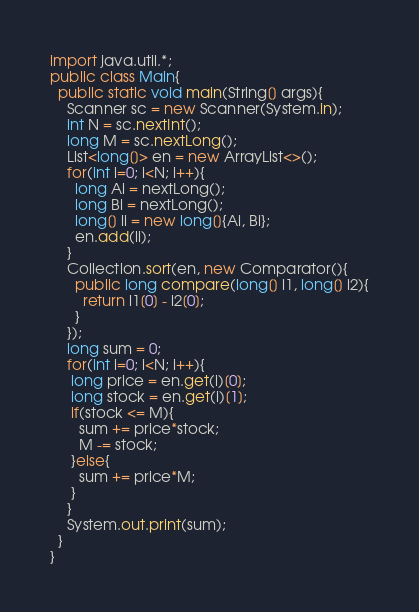Convert code to text. <code><loc_0><loc_0><loc_500><loc_500><_Java_>import java.util.*;
public class Main{
  public static void main(String[] args){
    Scanner sc = new Scanner(System.in);
    int N = sc.nextInt();
    long M = sc.nextLong();
    List<long[]> en = new ArrayList<>();
    for(int i=0; i<N; i++){
      long Ai = nextLong();
      long Bi = nextLong();
      long[] li = new long[]{Ai, Bi};
      en.add(li);
    }
    Collection.sort(en, new Comparator(){
      public long compare(long[] l1, long[] l2){
        return l1[0] - l2[0];
      }
    });
    long sum = 0;
    for(int i=0; i<N; i++){
     long price = en.get(i)[0];
     long stock = en.get(i)[1];
     if(stock <= M){
       sum += price*stock;
       M -= stock;
     }else{
       sum += price*M;
     }
    }
    System.out.print(sum);
  }
}
</code> 